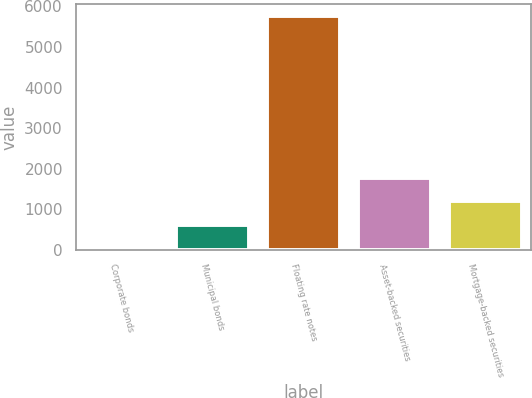<chart> <loc_0><loc_0><loc_500><loc_500><bar_chart><fcel>Corporate bonds<fcel>Municipal bonds<fcel>Floating rate notes<fcel>Asset-backed securities<fcel>Mortgage-backed securities<nl><fcel>49<fcel>620.3<fcel>5762<fcel>1762.9<fcel>1191.6<nl></chart> 